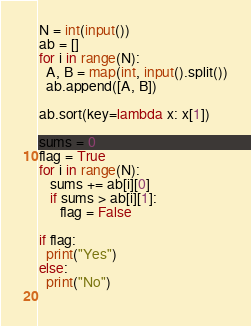Convert code to text. <code><loc_0><loc_0><loc_500><loc_500><_Python_>N = int(input())
ab = []
for i in range(N):
  A, B = map(int, input().split())
  ab.append([A, B])

ab.sort(key=lambda x: x[1])

sums = 0
flag = True
for i in range(N):
   sums += ab[i][0]
   if sums > ab[i][1]:
      flag = False

if flag:
  print("Yes")
else:
  print("No")
    </code> 